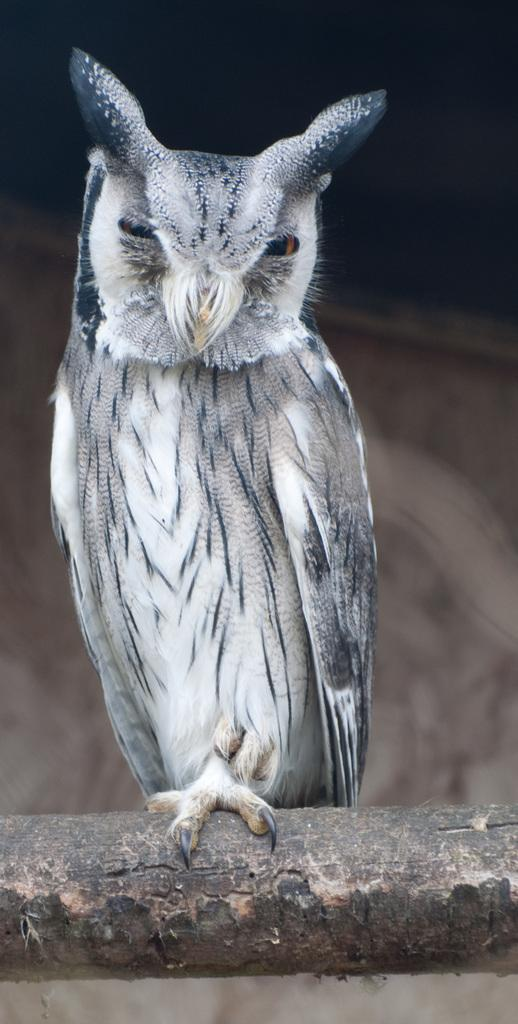What is the main subject of the image? There is a bird in the center of the image. Can you describe the bird in the image? The provided facts do not include a description of the bird, so we cannot provide any details about its appearance or behavior. How many cakes are on the bird's back in the image? There are no cakes present in the image, as it only features a bird in the center. 